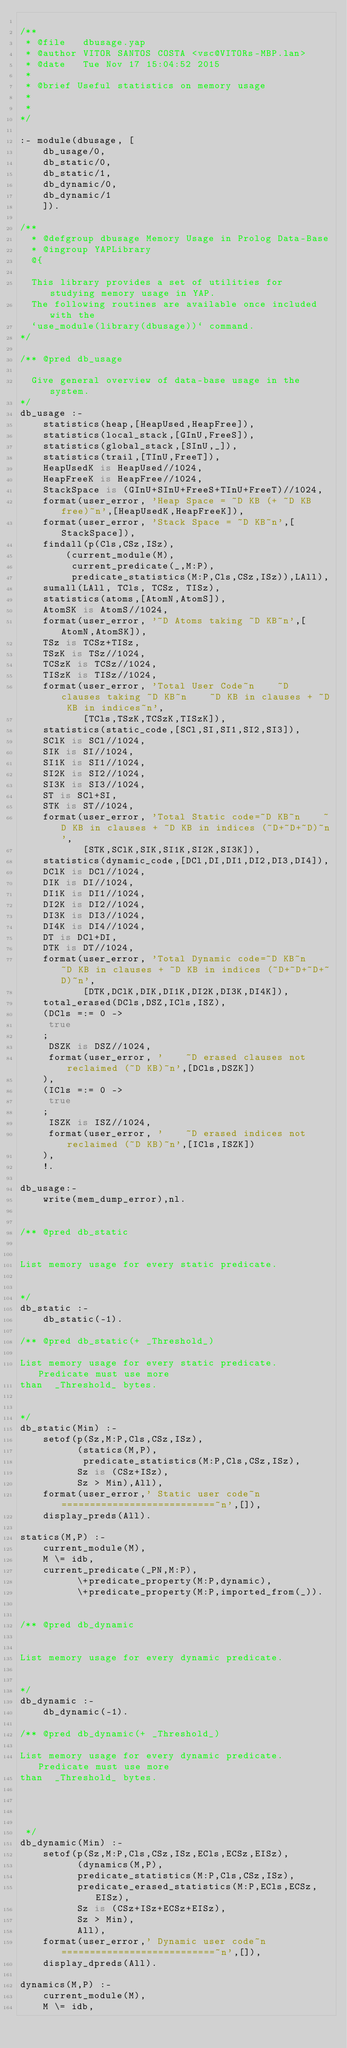Convert code to text. <code><loc_0><loc_0><loc_500><loc_500><_Prolog_>
/**
 * @file   dbusage.yap
 * @author VITOR SANTOS COSTA <vsc@VITORs-MBP.lan>
 * @date   Tue Nov 17 15:04:52 2015
 * 
 * @brief Useful statistics on memory usage
 * 
 * 
*/

:- module(dbusage, [
	db_usage/0,
	db_static/0,
	db_static/1,
	db_dynamic/0,
	db_dynamic/1
    ]).

/**
  * @defgroup dbusage Memory Usage in Prolog Data-Base
  * @ingroup YAPLibrary
  @{

  This library provides a set of utilities for studying memory usage in YAP.
  The following routines are available once included with the
  `use_module(library(dbusage))` command.
*/

/** @pred db_usage
  
  Give general overview of data-base usage in the system.
*/
db_usage :-
	statistics(heap,[HeapUsed,HeapFree]),
	statistics(local_stack,[GInU,FreeS]),
	statistics(global_stack,[SInU,_]),
	statistics(trail,[TInU,FreeT]),
	HeapUsedK is HeapUsed//1024,
	HeapFreeK is HeapFree//1024,
	StackSpace is (GInU+SInU+FreeS+TInU+FreeT)//1024,
	format(user_error, 'Heap Space = ~D KB (+ ~D KB free)~n',[HeapUsedK,HeapFreeK]),	
	format(user_error, 'Stack Space = ~D KB~n',[StackSpace]),
	findall(p(Cls,CSz,ISz),
		(current_module(M),
		 current_predicate(_,M:P),
		 predicate_statistics(M:P,Cls,CSz,ISz)),LAll),
	sumall(LAll, TCls, TCSz, TISz),
	statistics(atoms,[AtomN,AtomS]),
	AtomSK is AtomS//1024,
	format(user_error, '~D Atoms taking ~D KB~n',[AtomN,AtomSK]),
	TSz is TCSz+TISz,
	TSzK is TSz//1024,
	TCSzK is TCSz//1024,
	TISzK is TISz//1024,
	format(user_error, 'Total User Code~n    ~D clauses taking ~D KB~n    ~D KB in clauses + ~D KB in indices~n',
	       [TCls,TSzK,TCSzK,TISzK]),
	statistics(static_code,[SCl,SI,SI1,SI2,SI3]),
	SClK is SCl//1024,
	SIK is SI//1024,
	SI1K is SI1//1024,
	SI2K is SI2//1024,
	SI3K is SI3//1024,
	ST is SCl+SI,
	STK is ST//1024,
	format(user_error, 'Total Static code=~D KB~n    ~D KB in clauses + ~D KB in indices (~D+~D+~D)~n',
	       [STK,SClK,SIK,SI1K,SI2K,SI3K]),
	statistics(dynamic_code,[DCl,DI,DI1,DI2,DI3,DI4]),
	DClK is DCl//1024,
	DIK is DI//1024,
	DI1K is DI1//1024,
	DI2K is DI2//1024,
	DI3K is DI3//1024,
	DI4K is DI4//1024,
	DT is DCl+DI,
	DTK is DT//1024,
	format(user_error, 'Total Dynamic code=~D KB~n    ~D KB in clauses + ~D KB in indices (~D+~D+~D+~D)~n',
	       [DTK,DClK,DIK,DI1K,DI2K,DI3K,DI4K]),
	total_erased(DCls,DSZ,ICls,ISZ),
	(DCls =:= 0 ->
	 true
	;
	 DSZK is DSZ//1024,
	 format(user_error, '    ~D erased clauses not reclaimed (~D KB)~n',[DCls,DSZK])
	),
	(ICls =:= 0 ->
	 true
	;
	 ISZK is ISZ//1024,
	 format(user_error, '    ~D erased indices not reclaimed (~D KB)~n',[ICls,ISZK])
	),
	!.

db_usage:-
	write(mem_dump_error),nl.


/** @pred db_static 


List memory usage for every static predicate.

 
*/
db_static :-
    db_static(-1).

/** @pred db_static(+ _Threshold_)

List memory usage for every static predicate. Predicate must use more
than  _Threshold_ bytes.

 
*/
db_static(Min) :-
	setof(p(Sz,M:P,Cls,CSz,ISz),
	      (statics(M,P),
	       predicate_statistics(M:P,Cls,CSz,ISz),
		  Sz is (CSz+ISz),
		  Sz > Min),All),
	format(user_error,' Static user code~n===========================~n',[]),
	display_preds(All).

statics(M,P) :-
    current_module(M),
    M \= idb,
    current_predicate(_PN,M:P),
		  \+predicate_property(M:P,dynamic),
		  \+predicate_property(M:P,imported_from(_)).


/** @pred db_dynamic 


List memory usage for every dynamic predicate.

 
*/
db_dynamic :-
    db_dynamic(-1).

/** @pred db_dynamic(+ _Threshold_)

List memory usage for every dynamic predicate. Predicate must use more
than  _Threshold_ bytes.




 */
db_dynamic(Min) :-
	setof(p(Sz,M:P,Cls,CSz,ISz,ECls,ECSz,EISz),
	      (dynamics(M,P),
		  predicate_statistics(M:P,Cls,CSz,ISz),
		  predicate_erased_statistics(M:P,ECls,ECSz,EISz),
		  Sz is (CSz+ISz+ECSz+EISz),
		  Sz > Min),
	      All),
	format(user_error,' Dynamic user code~n===========================~n',[]),
	display_dpreds(All).

dynamics(M,P) :-
    current_module(M),
    M \= idb,</code> 